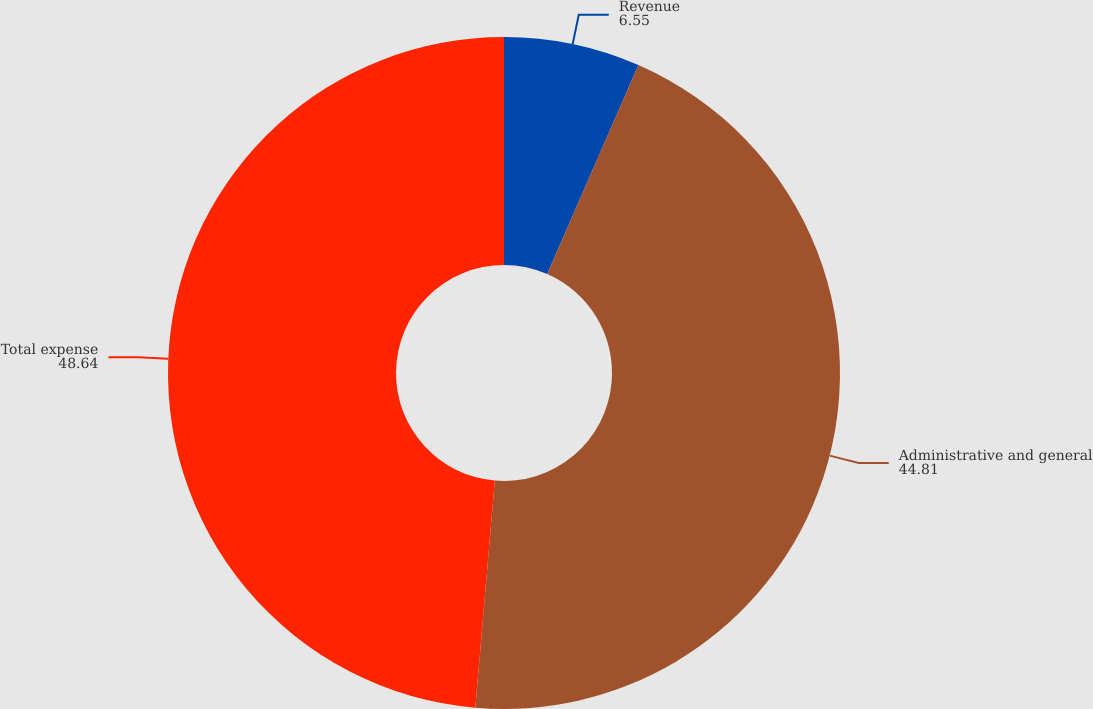Convert chart. <chart><loc_0><loc_0><loc_500><loc_500><pie_chart><fcel>Revenue<fcel>Administrative and general<fcel>Total expense<nl><fcel>6.55%<fcel>44.81%<fcel>48.64%<nl></chart> 